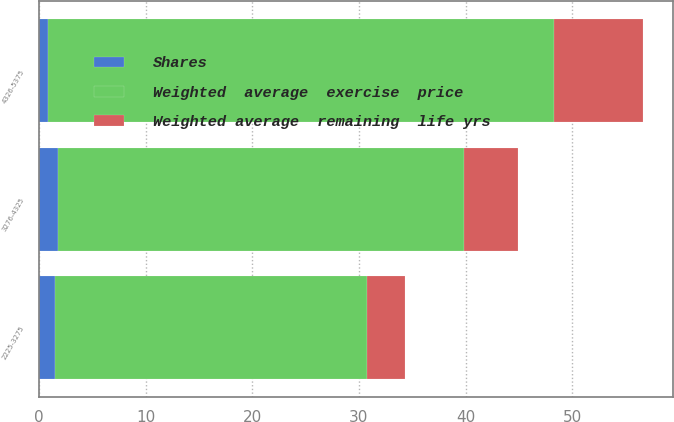<chart> <loc_0><loc_0><loc_500><loc_500><stacked_bar_chart><ecel><fcel>2225-3275<fcel>3276-4325<fcel>4326-5375<nl><fcel>Shares<fcel>1.5<fcel>1.8<fcel>0.9<nl><fcel>Weighted average  remaining  life yrs<fcel>3.6<fcel>5.1<fcel>8.3<nl><fcel>Weighted  average  exercise  price<fcel>29.25<fcel>38.05<fcel>47.4<nl></chart> 